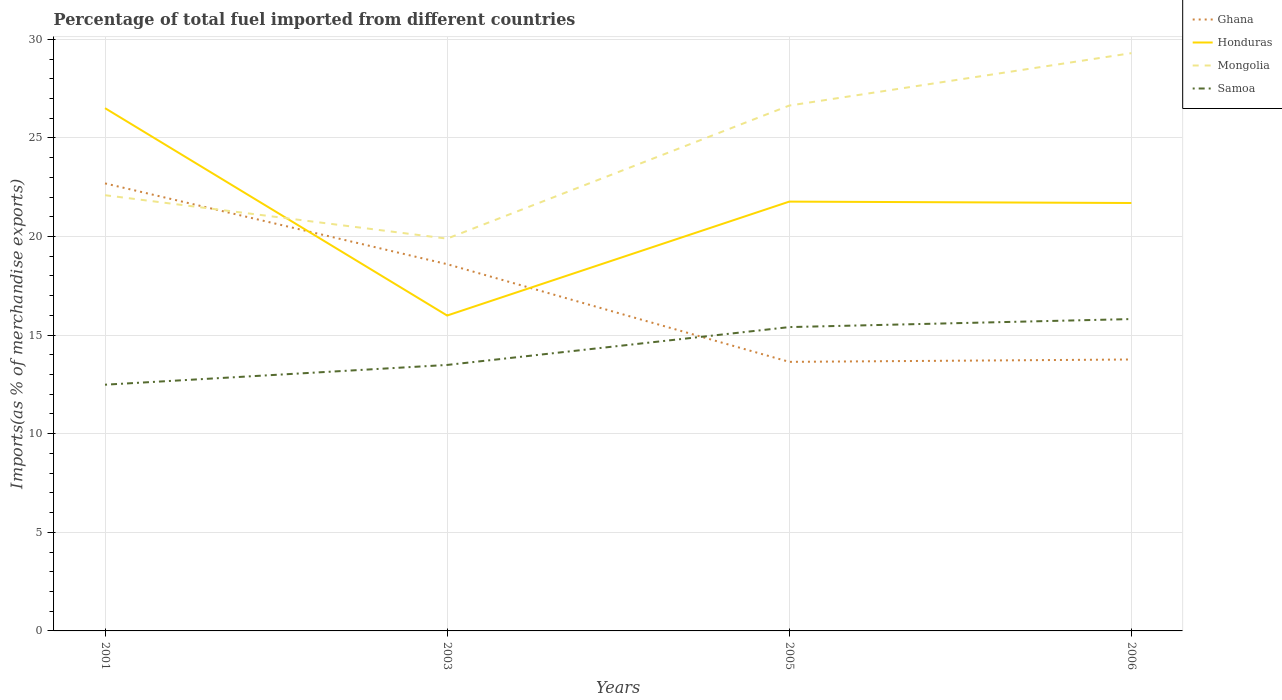How many different coloured lines are there?
Your answer should be compact. 4. Across all years, what is the maximum percentage of imports to different countries in Mongolia?
Provide a succinct answer. 19.89. What is the total percentage of imports to different countries in Mongolia in the graph?
Keep it short and to the point. -4.54. What is the difference between the highest and the second highest percentage of imports to different countries in Mongolia?
Offer a terse response. 9.41. What is the difference between the highest and the lowest percentage of imports to different countries in Samoa?
Offer a terse response. 2. How many lines are there?
Keep it short and to the point. 4. How many years are there in the graph?
Offer a terse response. 4. Are the values on the major ticks of Y-axis written in scientific E-notation?
Make the answer very short. No. Does the graph contain grids?
Keep it short and to the point. Yes. Where does the legend appear in the graph?
Offer a very short reply. Top right. How many legend labels are there?
Offer a very short reply. 4. What is the title of the graph?
Offer a very short reply. Percentage of total fuel imported from different countries. Does "Mauritania" appear as one of the legend labels in the graph?
Offer a terse response. No. What is the label or title of the X-axis?
Provide a succinct answer. Years. What is the label or title of the Y-axis?
Provide a short and direct response. Imports(as % of merchandise exports). What is the Imports(as % of merchandise exports) of Ghana in 2001?
Your answer should be compact. 22.69. What is the Imports(as % of merchandise exports) in Honduras in 2001?
Provide a succinct answer. 26.51. What is the Imports(as % of merchandise exports) of Mongolia in 2001?
Provide a succinct answer. 22.09. What is the Imports(as % of merchandise exports) in Samoa in 2001?
Your answer should be compact. 12.48. What is the Imports(as % of merchandise exports) in Ghana in 2003?
Make the answer very short. 18.6. What is the Imports(as % of merchandise exports) in Honduras in 2003?
Offer a terse response. 15.99. What is the Imports(as % of merchandise exports) in Mongolia in 2003?
Keep it short and to the point. 19.89. What is the Imports(as % of merchandise exports) in Samoa in 2003?
Ensure brevity in your answer.  13.49. What is the Imports(as % of merchandise exports) of Ghana in 2005?
Your answer should be compact. 13.64. What is the Imports(as % of merchandise exports) of Honduras in 2005?
Give a very brief answer. 21.77. What is the Imports(as % of merchandise exports) in Mongolia in 2005?
Make the answer very short. 26.64. What is the Imports(as % of merchandise exports) in Samoa in 2005?
Ensure brevity in your answer.  15.41. What is the Imports(as % of merchandise exports) of Ghana in 2006?
Make the answer very short. 13.76. What is the Imports(as % of merchandise exports) in Honduras in 2006?
Provide a succinct answer. 21.7. What is the Imports(as % of merchandise exports) in Mongolia in 2006?
Your response must be concise. 29.3. What is the Imports(as % of merchandise exports) in Samoa in 2006?
Provide a short and direct response. 15.81. Across all years, what is the maximum Imports(as % of merchandise exports) in Ghana?
Your answer should be very brief. 22.69. Across all years, what is the maximum Imports(as % of merchandise exports) in Honduras?
Your answer should be compact. 26.51. Across all years, what is the maximum Imports(as % of merchandise exports) in Mongolia?
Your answer should be very brief. 29.3. Across all years, what is the maximum Imports(as % of merchandise exports) of Samoa?
Keep it short and to the point. 15.81. Across all years, what is the minimum Imports(as % of merchandise exports) in Ghana?
Your answer should be very brief. 13.64. Across all years, what is the minimum Imports(as % of merchandise exports) of Honduras?
Your answer should be compact. 15.99. Across all years, what is the minimum Imports(as % of merchandise exports) in Mongolia?
Keep it short and to the point. 19.89. Across all years, what is the minimum Imports(as % of merchandise exports) of Samoa?
Offer a very short reply. 12.48. What is the total Imports(as % of merchandise exports) in Ghana in the graph?
Make the answer very short. 68.7. What is the total Imports(as % of merchandise exports) of Honduras in the graph?
Your answer should be compact. 85.97. What is the total Imports(as % of merchandise exports) of Mongolia in the graph?
Make the answer very short. 97.92. What is the total Imports(as % of merchandise exports) of Samoa in the graph?
Your answer should be compact. 57.19. What is the difference between the Imports(as % of merchandise exports) of Ghana in 2001 and that in 2003?
Ensure brevity in your answer.  4.1. What is the difference between the Imports(as % of merchandise exports) in Honduras in 2001 and that in 2003?
Give a very brief answer. 10.51. What is the difference between the Imports(as % of merchandise exports) in Mongolia in 2001 and that in 2003?
Offer a very short reply. 2.2. What is the difference between the Imports(as % of merchandise exports) in Samoa in 2001 and that in 2003?
Provide a succinct answer. -1. What is the difference between the Imports(as % of merchandise exports) in Ghana in 2001 and that in 2005?
Your response must be concise. 9.05. What is the difference between the Imports(as % of merchandise exports) of Honduras in 2001 and that in 2005?
Provide a succinct answer. 4.74. What is the difference between the Imports(as % of merchandise exports) in Mongolia in 2001 and that in 2005?
Your response must be concise. -4.54. What is the difference between the Imports(as % of merchandise exports) of Samoa in 2001 and that in 2005?
Your answer should be very brief. -2.92. What is the difference between the Imports(as % of merchandise exports) in Ghana in 2001 and that in 2006?
Ensure brevity in your answer.  8.93. What is the difference between the Imports(as % of merchandise exports) of Honduras in 2001 and that in 2006?
Your response must be concise. 4.81. What is the difference between the Imports(as % of merchandise exports) of Mongolia in 2001 and that in 2006?
Your response must be concise. -7.2. What is the difference between the Imports(as % of merchandise exports) of Samoa in 2001 and that in 2006?
Offer a terse response. -3.33. What is the difference between the Imports(as % of merchandise exports) of Ghana in 2003 and that in 2005?
Your answer should be compact. 4.95. What is the difference between the Imports(as % of merchandise exports) of Honduras in 2003 and that in 2005?
Your answer should be compact. -5.78. What is the difference between the Imports(as % of merchandise exports) in Mongolia in 2003 and that in 2005?
Give a very brief answer. -6.75. What is the difference between the Imports(as % of merchandise exports) of Samoa in 2003 and that in 2005?
Ensure brevity in your answer.  -1.92. What is the difference between the Imports(as % of merchandise exports) of Ghana in 2003 and that in 2006?
Your answer should be very brief. 4.83. What is the difference between the Imports(as % of merchandise exports) of Honduras in 2003 and that in 2006?
Give a very brief answer. -5.71. What is the difference between the Imports(as % of merchandise exports) of Mongolia in 2003 and that in 2006?
Your answer should be very brief. -9.41. What is the difference between the Imports(as % of merchandise exports) of Samoa in 2003 and that in 2006?
Ensure brevity in your answer.  -2.33. What is the difference between the Imports(as % of merchandise exports) of Ghana in 2005 and that in 2006?
Offer a terse response. -0.12. What is the difference between the Imports(as % of merchandise exports) in Honduras in 2005 and that in 2006?
Offer a very short reply. 0.07. What is the difference between the Imports(as % of merchandise exports) of Mongolia in 2005 and that in 2006?
Your answer should be compact. -2.66. What is the difference between the Imports(as % of merchandise exports) of Samoa in 2005 and that in 2006?
Ensure brevity in your answer.  -0.41. What is the difference between the Imports(as % of merchandise exports) in Ghana in 2001 and the Imports(as % of merchandise exports) in Honduras in 2003?
Give a very brief answer. 6.7. What is the difference between the Imports(as % of merchandise exports) of Ghana in 2001 and the Imports(as % of merchandise exports) of Mongolia in 2003?
Make the answer very short. 2.8. What is the difference between the Imports(as % of merchandise exports) in Ghana in 2001 and the Imports(as % of merchandise exports) in Samoa in 2003?
Your response must be concise. 9.21. What is the difference between the Imports(as % of merchandise exports) in Honduras in 2001 and the Imports(as % of merchandise exports) in Mongolia in 2003?
Ensure brevity in your answer.  6.62. What is the difference between the Imports(as % of merchandise exports) of Honduras in 2001 and the Imports(as % of merchandise exports) of Samoa in 2003?
Provide a short and direct response. 13.02. What is the difference between the Imports(as % of merchandise exports) of Mongolia in 2001 and the Imports(as % of merchandise exports) of Samoa in 2003?
Keep it short and to the point. 8.61. What is the difference between the Imports(as % of merchandise exports) of Ghana in 2001 and the Imports(as % of merchandise exports) of Honduras in 2005?
Make the answer very short. 0.92. What is the difference between the Imports(as % of merchandise exports) in Ghana in 2001 and the Imports(as % of merchandise exports) in Mongolia in 2005?
Offer a very short reply. -3.95. What is the difference between the Imports(as % of merchandise exports) in Ghana in 2001 and the Imports(as % of merchandise exports) in Samoa in 2005?
Give a very brief answer. 7.29. What is the difference between the Imports(as % of merchandise exports) of Honduras in 2001 and the Imports(as % of merchandise exports) of Mongolia in 2005?
Provide a succinct answer. -0.13. What is the difference between the Imports(as % of merchandise exports) in Honduras in 2001 and the Imports(as % of merchandise exports) in Samoa in 2005?
Offer a very short reply. 11.1. What is the difference between the Imports(as % of merchandise exports) in Mongolia in 2001 and the Imports(as % of merchandise exports) in Samoa in 2005?
Your answer should be compact. 6.69. What is the difference between the Imports(as % of merchandise exports) in Ghana in 2001 and the Imports(as % of merchandise exports) in Honduras in 2006?
Give a very brief answer. 0.99. What is the difference between the Imports(as % of merchandise exports) of Ghana in 2001 and the Imports(as % of merchandise exports) of Mongolia in 2006?
Your answer should be very brief. -6.6. What is the difference between the Imports(as % of merchandise exports) of Ghana in 2001 and the Imports(as % of merchandise exports) of Samoa in 2006?
Your answer should be very brief. 6.88. What is the difference between the Imports(as % of merchandise exports) of Honduras in 2001 and the Imports(as % of merchandise exports) of Mongolia in 2006?
Your response must be concise. -2.79. What is the difference between the Imports(as % of merchandise exports) in Honduras in 2001 and the Imports(as % of merchandise exports) in Samoa in 2006?
Offer a very short reply. 10.69. What is the difference between the Imports(as % of merchandise exports) of Mongolia in 2001 and the Imports(as % of merchandise exports) of Samoa in 2006?
Your response must be concise. 6.28. What is the difference between the Imports(as % of merchandise exports) of Ghana in 2003 and the Imports(as % of merchandise exports) of Honduras in 2005?
Make the answer very short. -3.17. What is the difference between the Imports(as % of merchandise exports) of Ghana in 2003 and the Imports(as % of merchandise exports) of Mongolia in 2005?
Keep it short and to the point. -8.04. What is the difference between the Imports(as % of merchandise exports) in Ghana in 2003 and the Imports(as % of merchandise exports) in Samoa in 2005?
Ensure brevity in your answer.  3.19. What is the difference between the Imports(as % of merchandise exports) in Honduras in 2003 and the Imports(as % of merchandise exports) in Mongolia in 2005?
Offer a terse response. -10.65. What is the difference between the Imports(as % of merchandise exports) of Honduras in 2003 and the Imports(as % of merchandise exports) of Samoa in 2005?
Your response must be concise. 0.59. What is the difference between the Imports(as % of merchandise exports) in Mongolia in 2003 and the Imports(as % of merchandise exports) in Samoa in 2005?
Provide a short and direct response. 4.49. What is the difference between the Imports(as % of merchandise exports) in Ghana in 2003 and the Imports(as % of merchandise exports) in Honduras in 2006?
Give a very brief answer. -3.1. What is the difference between the Imports(as % of merchandise exports) of Ghana in 2003 and the Imports(as % of merchandise exports) of Mongolia in 2006?
Your answer should be compact. -10.7. What is the difference between the Imports(as % of merchandise exports) in Ghana in 2003 and the Imports(as % of merchandise exports) in Samoa in 2006?
Give a very brief answer. 2.78. What is the difference between the Imports(as % of merchandise exports) in Honduras in 2003 and the Imports(as % of merchandise exports) in Mongolia in 2006?
Your answer should be compact. -13.3. What is the difference between the Imports(as % of merchandise exports) in Honduras in 2003 and the Imports(as % of merchandise exports) in Samoa in 2006?
Provide a succinct answer. 0.18. What is the difference between the Imports(as % of merchandise exports) in Mongolia in 2003 and the Imports(as % of merchandise exports) in Samoa in 2006?
Give a very brief answer. 4.08. What is the difference between the Imports(as % of merchandise exports) in Ghana in 2005 and the Imports(as % of merchandise exports) in Honduras in 2006?
Your response must be concise. -8.05. What is the difference between the Imports(as % of merchandise exports) of Ghana in 2005 and the Imports(as % of merchandise exports) of Mongolia in 2006?
Your response must be concise. -15.65. What is the difference between the Imports(as % of merchandise exports) in Ghana in 2005 and the Imports(as % of merchandise exports) in Samoa in 2006?
Provide a succinct answer. -2.17. What is the difference between the Imports(as % of merchandise exports) of Honduras in 2005 and the Imports(as % of merchandise exports) of Mongolia in 2006?
Your response must be concise. -7.53. What is the difference between the Imports(as % of merchandise exports) of Honduras in 2005 and the Imports(as % of merchandise exports) of Samoa in 2006?
Give a very brief answer. 5.96. What is the difference between the Imports(as % of merchandise exports) in Mongolia in 2005 and the Imports(as % of merchandise exports) in Samoa in 2006?
Make the answer very short. 10.83. What is the average Imports(as % of merchandise exports) in Ghana per year?
Offer a very short reply. 17.17. What is the average Imports(as % of merchandise exports) in Honduras per year?
Give a very brief answer. 21.49. What is the average Imports(as % of merchandise exports) of Mongolia per year?
Your response must be concise. 24.48. What is the average Imports(as % of merchandise exports) of Samoa per year?
Provide a short and direct response. 14.3. In the year 2001, what is the difference between the Imports(as % of merchandise exports) of Ghana and Imports(as % of merchandise exports) of Honduras?
Make the answer very short. -3.81. In the year 2001, what is the difference between the Imports(as % of merchandise exports) of Ghana and Imports(as % of merchandise exports) of Mongolia?
Keep it short and to the point. 0.6. In the year 2001, what is the difference between the Imports(as % of merchandise exports) in Ghana and Imports(as % of merchandise exports) in Samoa?
Provide a succinct answer. 10.21. In the year 2001, what is the difference between the Imports(as % of merchandise exports) of Honduras and Imports(as % of merchandise exports) of Mongolia?
Provide a succinct answer. 4.41. In the year 2001, what is the difference between the Imports(as % of merchandise exports) in Honduras and Imports(as % of merchandise exports) in Samoa?
Give a very brief answer. 14.02. In the year 2001, what is the difference between the Imports(as % of merchandise exports) of Mongolia and Imports(as % of merchandise exports) of Samoa?
Make the answer very short. 9.61. In the year 2003, what is the difference between the Imports(as % of merchandise exports) of Ghana and Imports(as % of merchandise exports) of Honduras?
Offer a very short reply. 2.6. In the year 2003, what is the difference between the Imports(as % of merchandise exports) of Ghana and Imports(as % of merchandise exports) of Mongolia?
Your answer should be compact. -1.3. In the year 2003, what is the difference between the Imports(as % of merchandise exports) of Ghana and Imports(as % of merchandise exports) of Samoa?
Your answer should be very brief. 5.11. In the year 2003, what is the difference between the Imports(as % of merchandise exports) in Honduras and Imports(as % of merchandise exports) in Mongolia?
Your answer should be compact. -3.9. In the year 2003, what is the difference between the Imports(as % of merchandise exports) in Honduras and Imports(as % of merchandise exports) in Samoa?
Your answer should be compact. 2.51. In the year 2003, what is the difference between the Imports(as % of merchandise exports) of Mongolia and Imports(as % of merchandise exports) of Samoa?
Provide a succinct answer. 6.4. In the year 2005, what is the difference between the Imports(as % of merchandise exports) in Ghana and Imports(as % of merchandise exports) in Honduras?
Ensure brevity in your answer.  -8.13. In the year 2005, what is the difference between the Imports(as % of merchandise exports) in Ghana and Imports(as % of merchandise exports) in Mongolia?
Provide a succinct answer. -13. In the year 2005, what is the difference between the Imports(as % of merchandise exports) of Ghana and Imports(as % of merchandise exports) of Samoa?
Ensure brevity in your answer.  -1.76. In the year 2005, what is the difference between the Imports(as % of merchandise exports) of Honduras and Imports(as % of merchandise exports) of Mongolia?
Provide a short and direct response. -4.87. In the year 2005, what is the difference between the Imports(as % of merchandise exports) in Honduras and Imports(as % of merchandise exports) in Samoa?
Ensure brevity in your answer.  6.36. In the year 2005, what is the difference between the Imports(as % of merchandise exports) of Mongolia and Imports(as % of merchandise exports) of Samoa?
Give a very brief answer. 11.23. In the year 2006, what is the difference between the Imports(as % of merchandise exports) of Ghana and Imports(as % of merchandise exports) of Honduras?
Give a very brief answer. -7.93. In the year 2006, what is the difference between the Imports(as % of merchandise exports) of Ghana and Imports(as % of merchandise exports) of Mongolia?
Your response must be concise. -15.53. In the year 2006, what is the difference between the Imports(as % of merchandise exports) of Ghana and Imports(as % of merchandise exports) of Samoa?
Offer a very short reply. -2.05. In the year 2006, what is the difference between the Imports(as % of merchandise exports) in Honduras and Imports(as % of merchandise exports) in Mongolia?
Provide a succinct answer. -7.6. In the year 2006, what is the difference between the Imports(as % of merchandise exports) of Honduras and Imports(as % of merchandise exports) of Samoa?
Offer a very short reply. 5.88. In the year 2006, what is the difference between the Imports(as % of merchandise exports) in Mongolia and Imports(as % of merchandise exports) in Samoa?
Provide a short and direct response. 13.48. What is the ratio of the Imports(as % of merchandise exports) in Ghana in 2001 to that in 2003?
Offer a terse response. 1.22. What is the ratio of the Imports(as % of merchandise exports) of Honduras in 2001 to that in 2003?
Ensure brevity in your answer.  1.66. What is the ratio of the Imports(as % of merchandise exports) of Mongolia in 2001 to that in 2003?
Provide a short and direct response. 1.11. What is the ratio of the Imports(as % of merchandise exports) of Samoa in 2001 to that in 2003?
Provide a short and direct response. 0.93. What is the ratio of the Imports(as % of merchandise exports) of Ghana in 2001 to that in 2005?
Offer a very short reply. 1.66. What is the ratio of the Imports(as % of merchandise exports) of Honduras in 2001 to that in 2005?
Your answer should be very brief. 1.22. What is the ratio of the Imports(as % of merchandise exports) of Mongolia in 2001 to that in 2005?
Give a very brief answer. 0.83. What is the ratio of the Imports(as % of merchandise exports) of Samoa in 2001 to that in 2005?
Make the answer very short. 0.81. What is the ratio of the Imports(as % of merchandise exports) of Ghana in 2001 to that in 2006?
Provide a succinct answer. 1.65. What is the ratio of the Imports(as % of merchandise exports) of Honduras in 2001 to that in 2006?
Your response must be concise. 1.22. What is the ratio of the Imports(as % of merchandise exports) of Mongolia in 2001 to that in 2006?
Provide a succinct answer. 0.75. What is the ratio of the Imports(as % of merchandise exports) of Samoa in 2001 to that in 2006?
Offer a very short reply. 0.79. What is the ratio of the Imports(as % of merchandise exports) of Ghana in 2003 to that in 2005?
Provide a short and direct response. 1.36. What is the ratio of the Imports(as % of merchandise exports) in Honduras in 2003 to that in 2005?
Provide a short and direct response. 0.73. What is the ratio of the Imports(as % of merchandise exports) in Mongolia in 2003 to that in 2005?
Give a very brief answer. 0.75. What is the ratio of the Imports(as % of merchandise exports) in Samoa in 2003 to that in 2005?
Ensure brevity in your answer.  0.88. What is the ratio of the Imports(as % of merchandise exports) of Ghana in 2003 to that in 2006?
Make the answer very short. 1.35. What is the ratio of the Imports(as % of merchandise exports) in Honduras in 2003 to that in 2006?
Offer a terse response. 0.74. What is the ratio of the Imports(as % of merchandise exports) of Mongolia in 2003 to that in 2006?
Provide a succinct answer. 0.68. What is the ratio of the Imports(as % of merchandise exports) of Samoa in 2003 to that in 2006?
Provide a short and direct response. 0.85. What is the ratio of the Imports(as % of merchandise exports) in Honduras in 2005 to that in 2006?
Ensure brevity in your answer.  1. What is the ratio of the Imports(as % of merchandise exports) of Mongolia in 2005 to that in 2006?
Offer a very short reply. 0.91. What is the ratio of the Imports(as % of merchandise exports) in Samoa in 2005 to that in 2006?
Provide a short and direct response. 0.97. What is the difference between the highest and the second highest Imports(as % of merchandise exports) in Ghana?
Your response must be concise. 4.1. What is the difference between the highest and the second highest Imports(as % of merchandise exports) of Honduras?
Make the answer very short. 4.74. What is the difference between the highest and the second highest Imports(as % of merchandise exports) of Mongolia?
Make the answer very short. 2.66. What is the difference between the highest and the second highest Imports(as % of merchandise exports) of Samoa?
Your response must be concise. 0.41. What is the difference between the highest and the lowest Imports(as % of merchandise exports) in Ghana?
Offer a very short reply. 9.05. What is the difference between the highest and the lowest Imports(as % of merchandise exports) in Honduras?
Offer a terse response. 10.51. What is the difference between the highest and the lowest Imports(as % of merchandise exports) in Mongolia?
Give a very brief answer. 9.41. What is the difference between the highest and the lowest Imports(as % of merchandise exports) of Samoa?
Give a very brief answer. 3.33. 